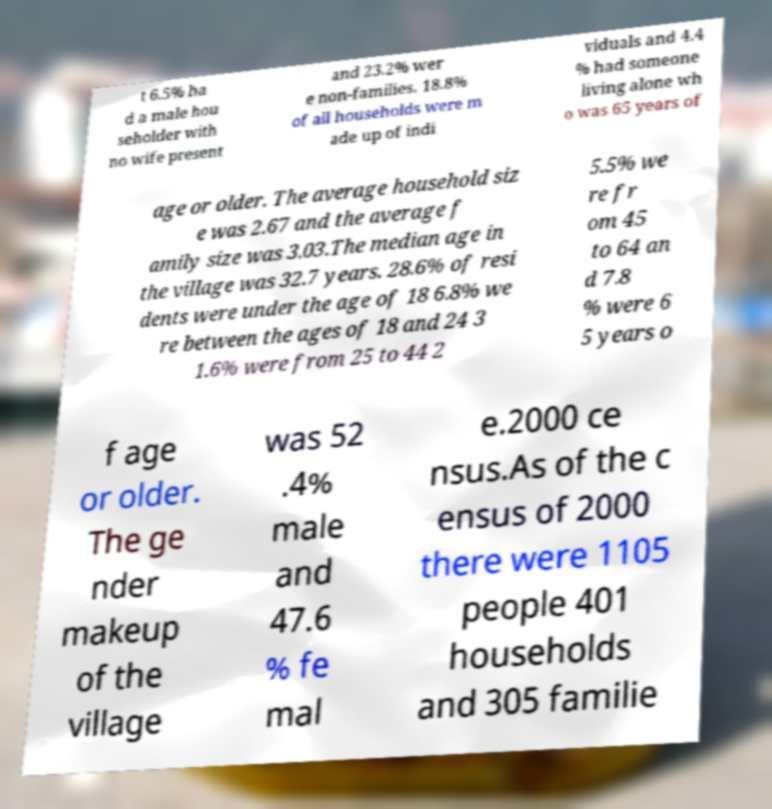Could you extract and type out the text from this image? t 6.5% ha d a male hou seholder with no wife present and 23.2% wer e non-families. 18.8% of all households were m ade up of indi viduals and 4.4 % had someone living alone wh o was 65 years of age or older. The average household siz e was 2.67 and the average f amily size was 3.03.The median age in the village was 32.7 years. 28.6% of resi dents were under the age of 18 6.8% we re between the ages of 18 and 24 3 1.6% were from 25 to 44 2 5.5% we re fr om 45 to 64 an d 7.8 % were 6 5 years o f age or older. The ge nder makeup of the village was 52 .4% male and 47.6 % fe mal e.2000 ce nsus.As of the c ensus of 2000 there were 1105 people 401 households and 305 familie 